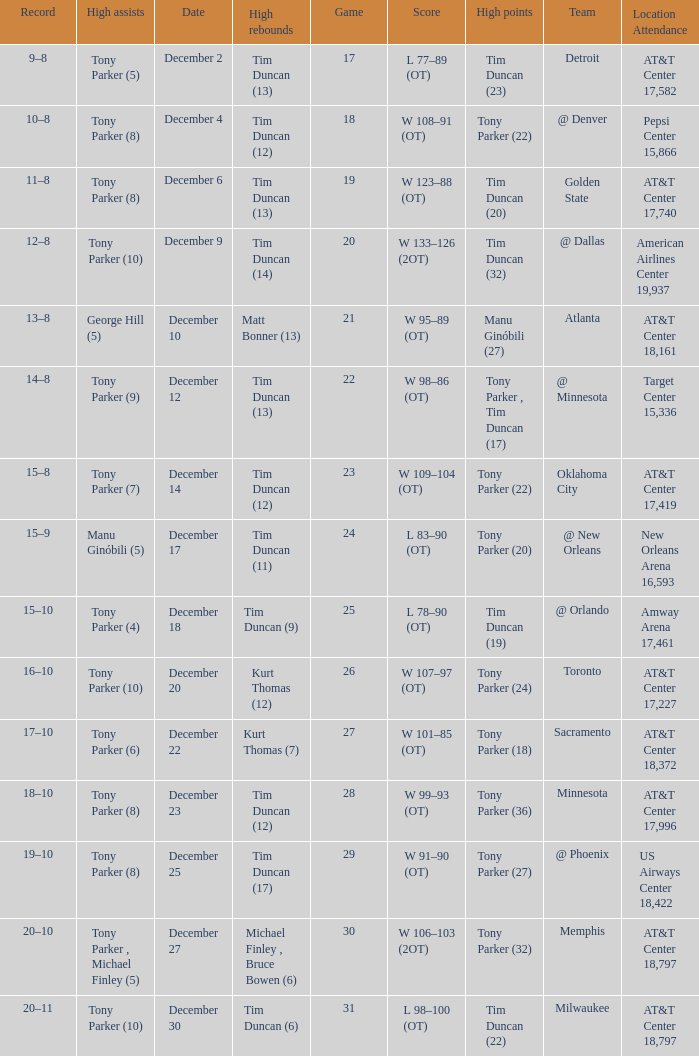What team has tony parker (10) as the high assists, kurt thomas (12) as the high rebounds? Toronto. 